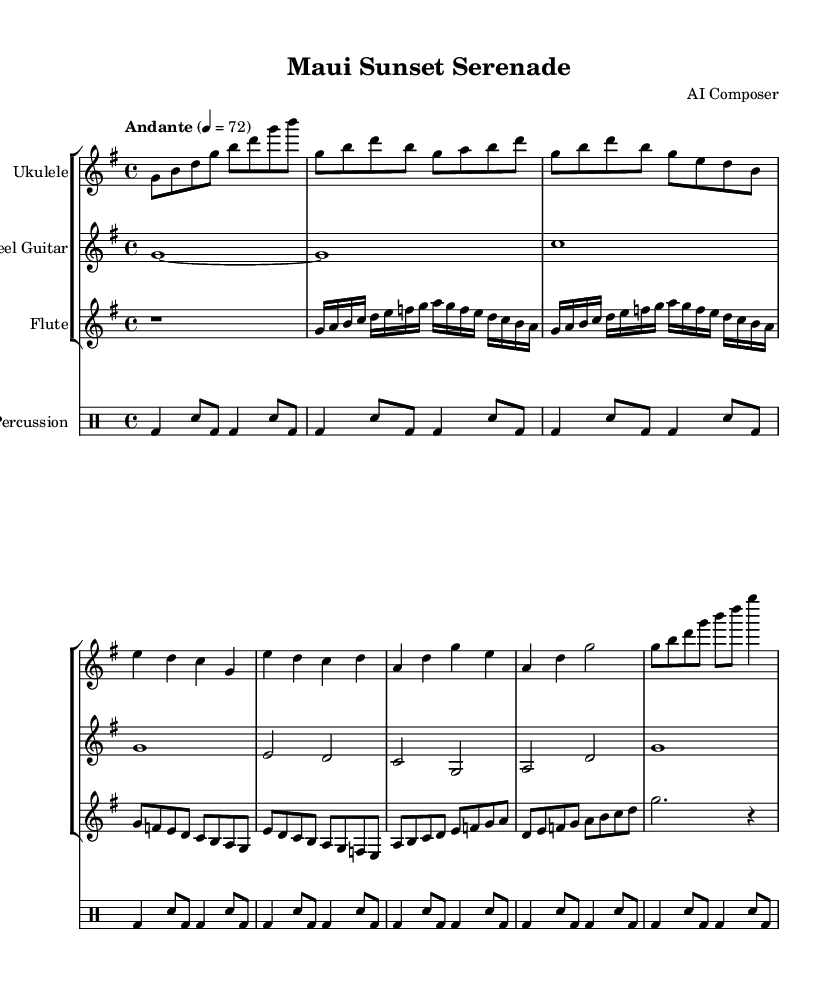What is the key signature of this music? The key signature is G major, which has one sharp (F#). This can be determined by looking at the key signature indicated at the beginning of the music, right after the clef.
Answer: G major What is the time signature of this piece? The time signature is 4/4, indicated at the beginning of the score next to the key signature. This means there are four beats in a measure, and the quarter note gets one beat.
Answer: 4/4 What is the tempo marking of this piece? The tempo marking is "Andante," which indicates a moderately slow tempo. It is located near the beginning of the score where tempo instructions are typically indicated.
Answer: Andante How many unique instruments are featured in this composition? The composition features four unique instruments: Ukulele, Steel Guitar, Flute, and Percussion. This can be observed in the score section where each instrument is identified in the staff names.
Answer: Four How many measures does the ukulele part contain? The ukulele part contains 8 measures as counted from the notation in the sheet music. Each measure is separated by vertical lines, making it easy to count.
Answer: 8 What is the duration of the first note played by the Steel Guitar? The first note played by the Steel Guitar is a whole note, lasting for four beats. This can be identified by the shape of the note and its placement in the first measure of the Steel Guitar part.
Answer: Whole note Which instrument primarily plays the melody in this piece? The flute primarily plays the melody, as it has the first melodic notes presented after the rest in the musical arrangement, showcasing more complex melodic lines.
Answer: Flute 